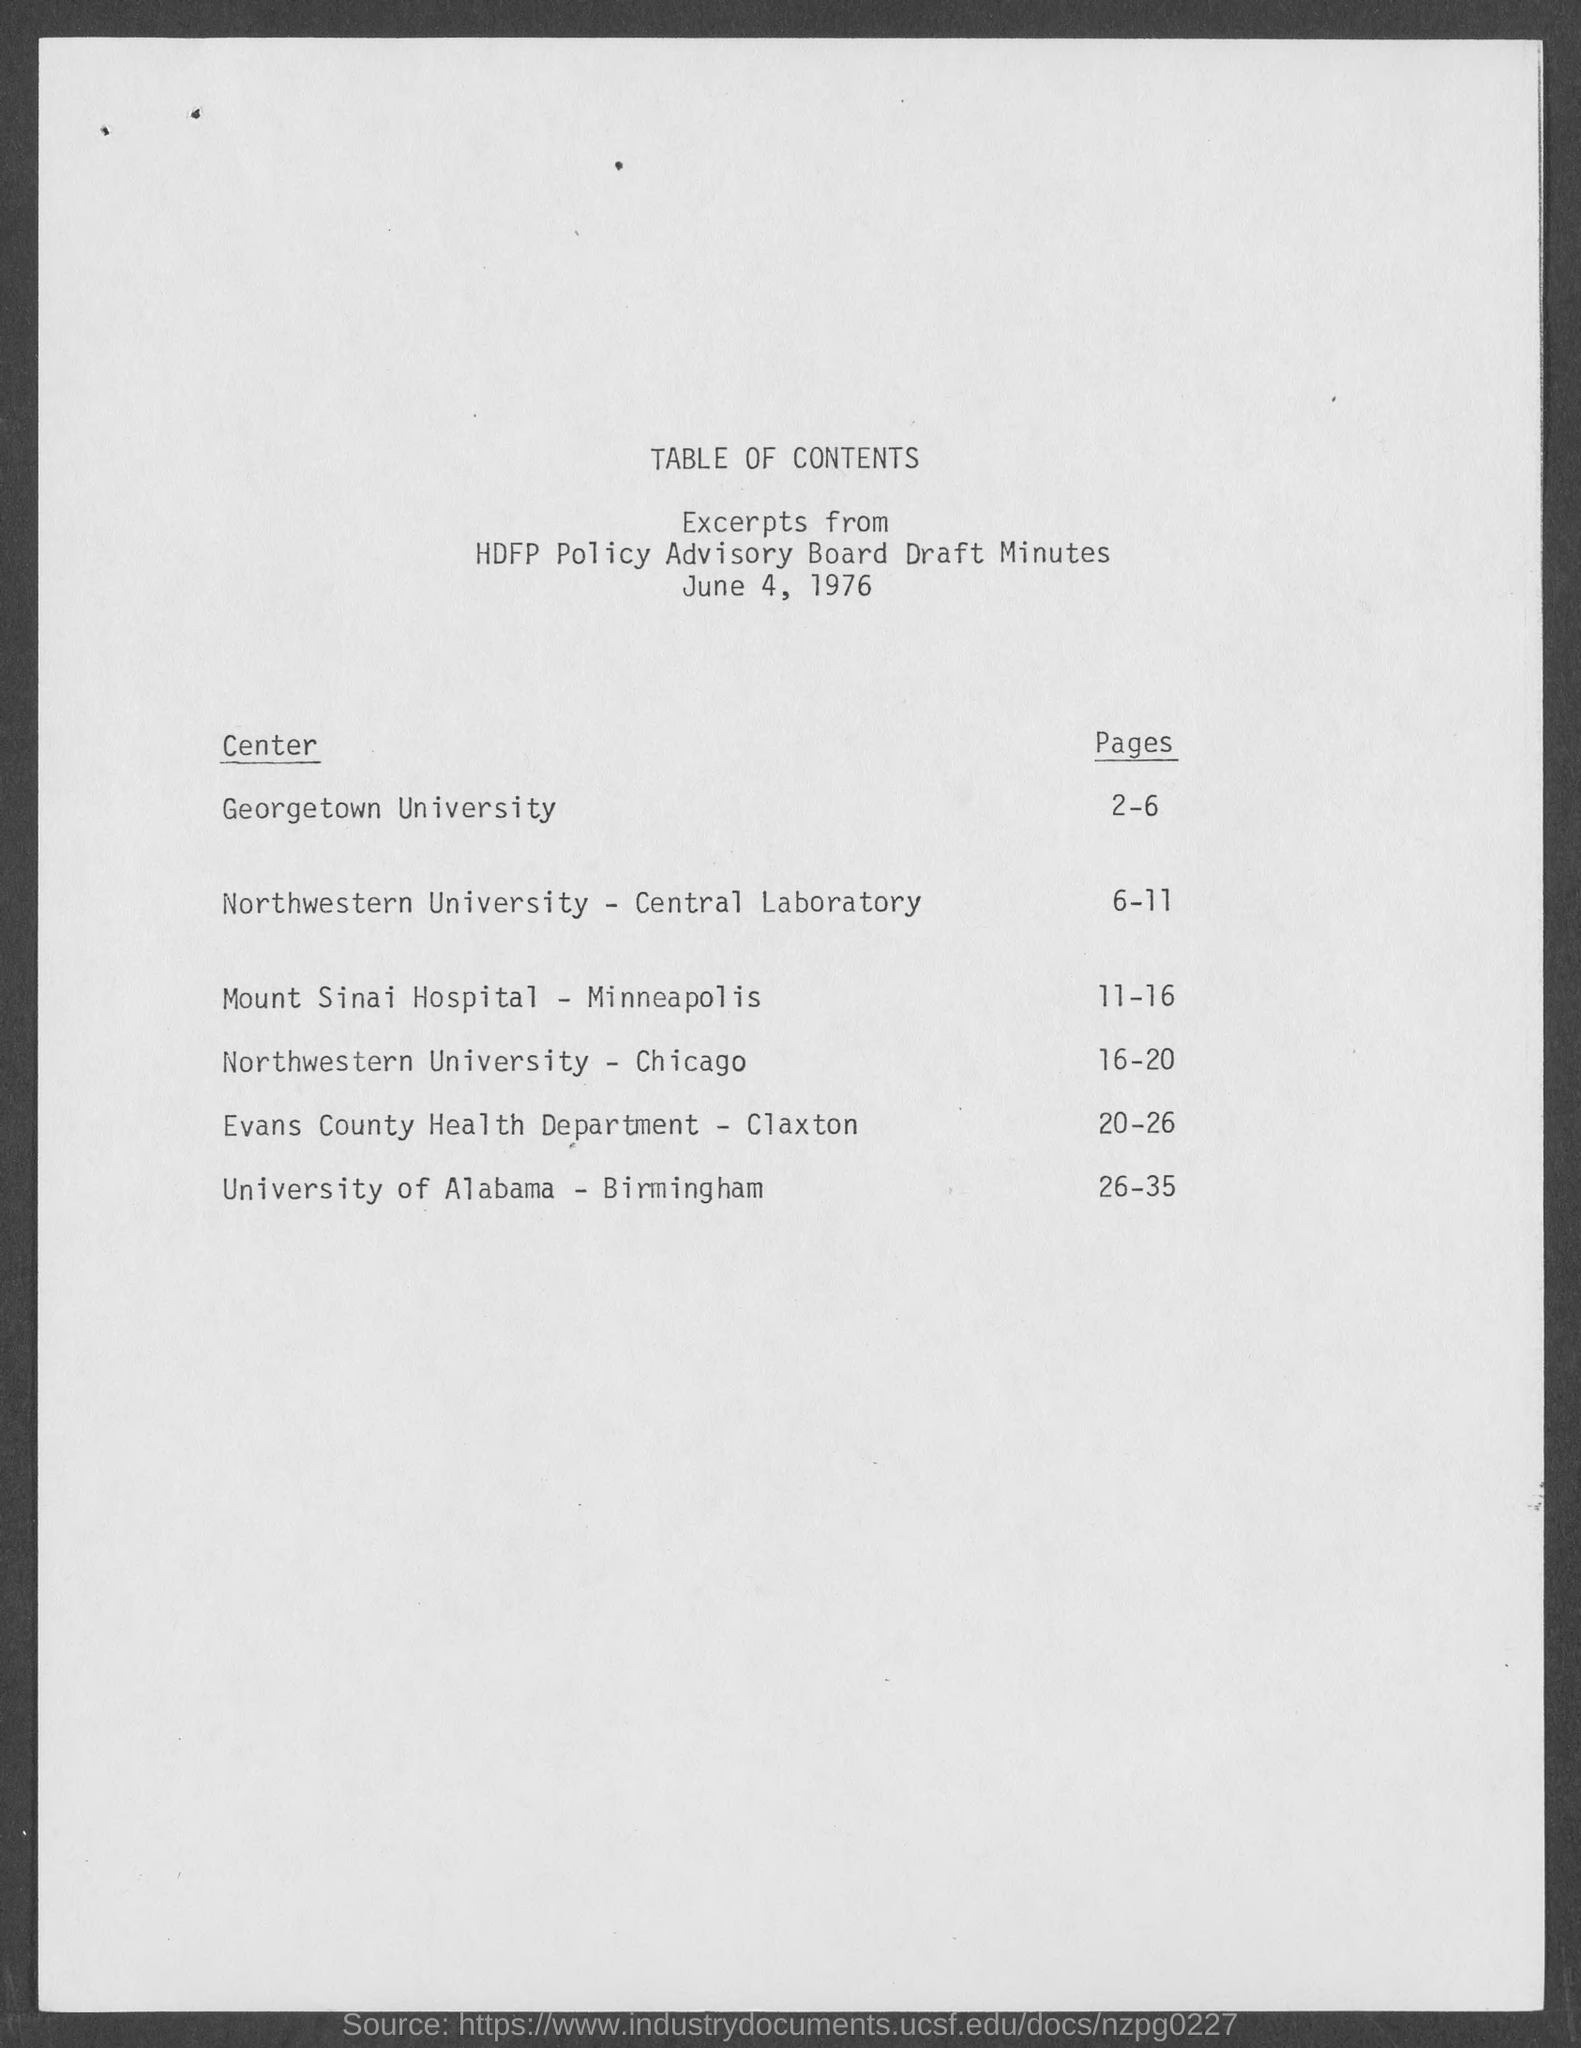What is the date mentioned in this document?
Provide a succinct answer. June 4, 1976. 